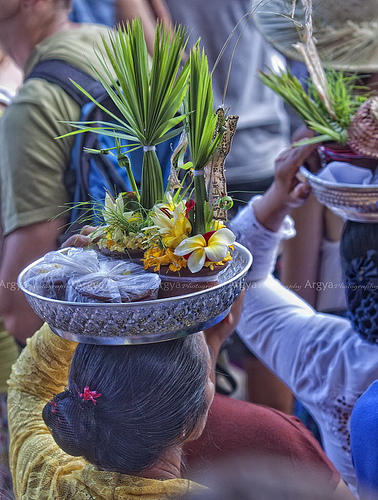<image>
Is there a plant in the bowl? Yes. The plant is contained within or inside the bowl, showing a containment relationship. Is there a woman on the bookbag? No. The woman is not positioned on the bookbag. They may be near each other, but the woman is not supported by or resting on top of the bookbag. 